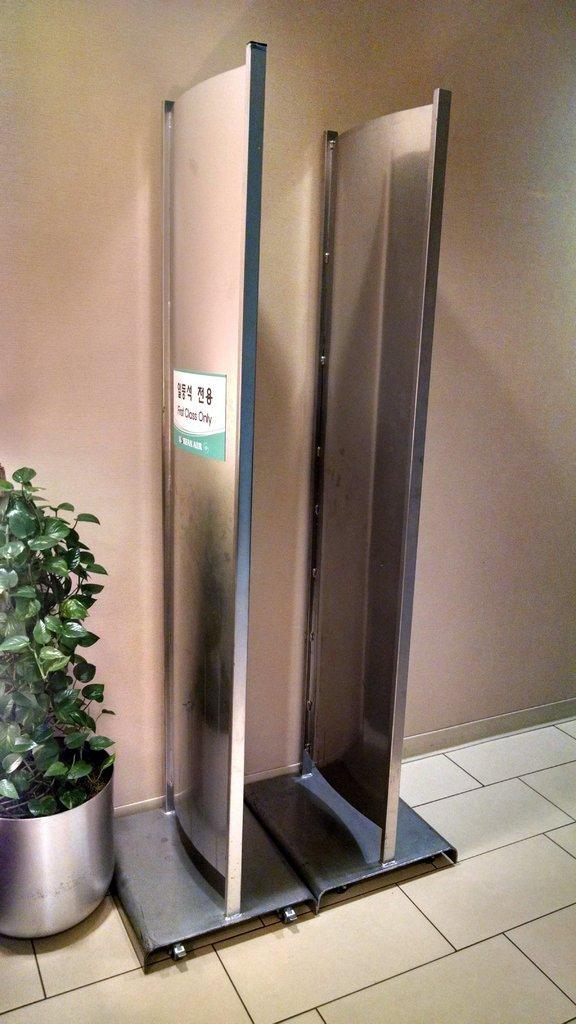In one or two sentences, can you explain what this image depicts? In the center of the image, we can see a stand and a flower pot and in the background, there is a wall. At the bottom, there is floor. 